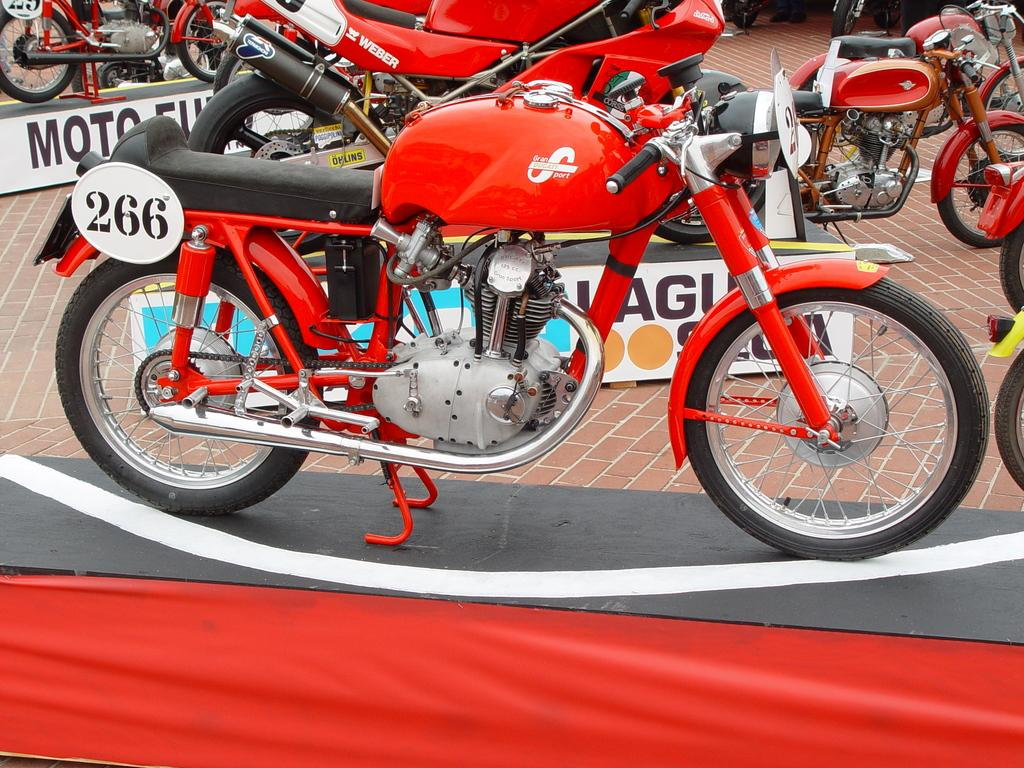What type of vehicle is in the image? There is a motorbike in the image. Where is the motorbike located? The motorbike is parked on a table. What color is the cloth in the image? There is a red cloth in the image. What can be seen in the background of the image? There are vehicles and the floor visible in the background. What type of decorations are present in the image? There are banners in the image. What type of health benefits can be gained from the popcorn in the image? There is no popcorn present in the image, so it is not possible to discuss any health benefits. 